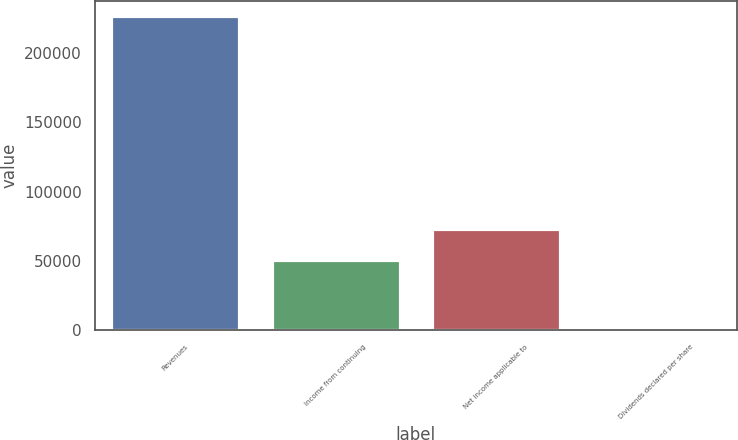<chart> <loc_0><loc_0><loc_500><loc_500><bar_chart><fcel>Revenues<fcel>Income from continuing<fcel>Net income applicable to<fcel>Dividends declared per share<nl><fcel>226294<fcel>50643.3<fcel>73272.7<fcel>0.47<nl></chart> 